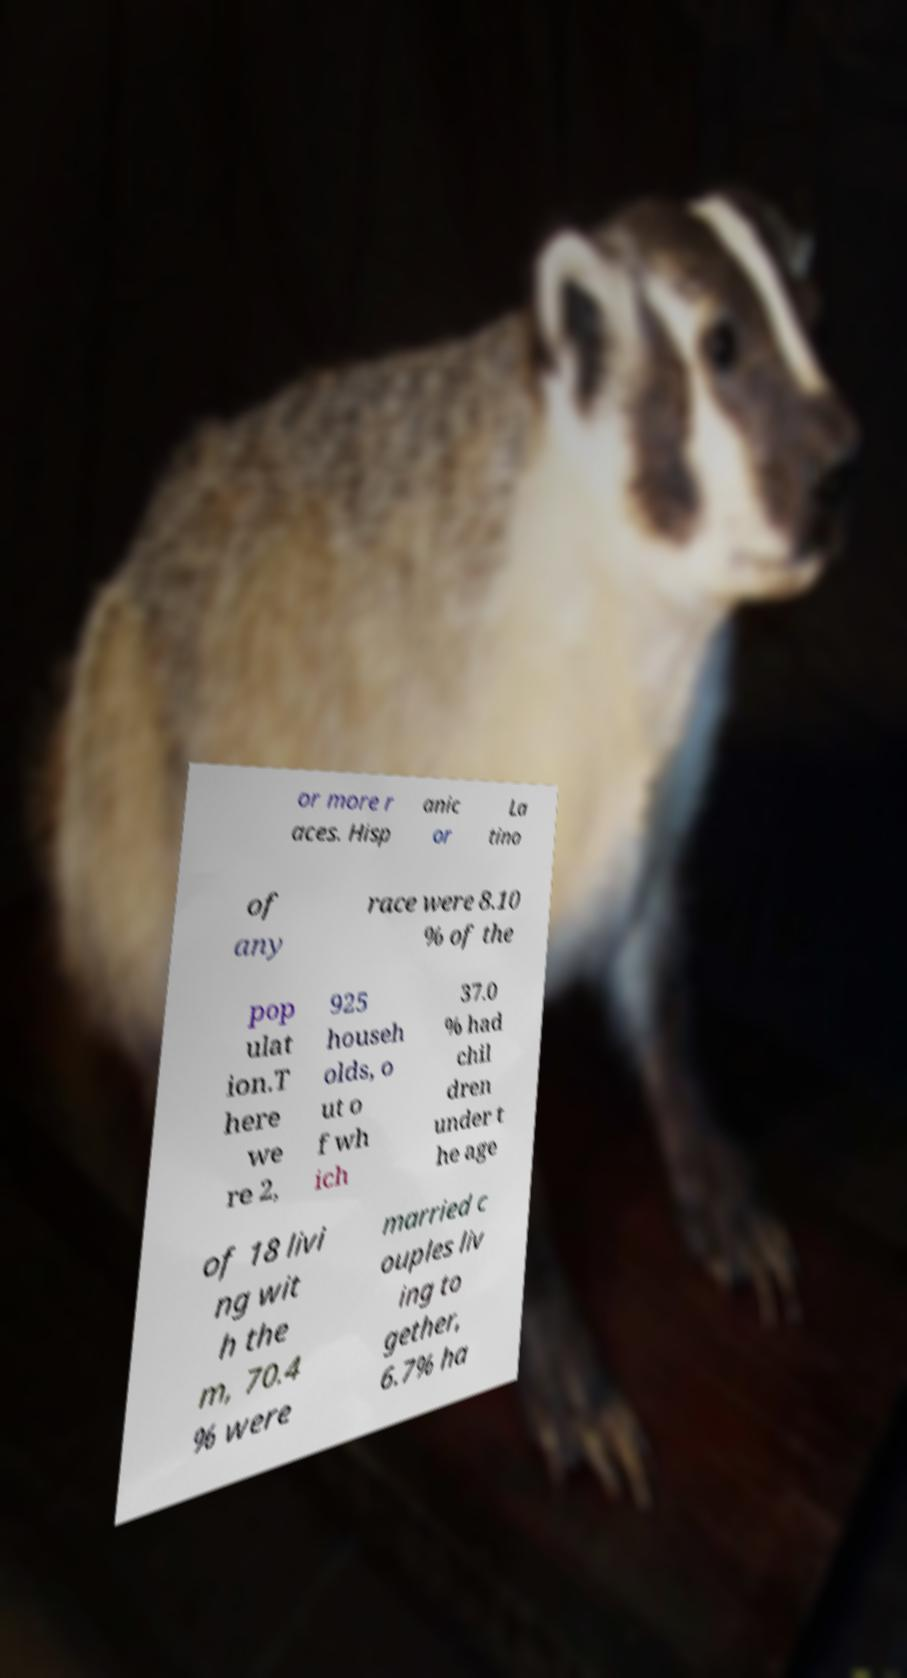Could you extract and type out the text from this image? or more r aces. Hisp anic or La tino of any race were 8.10 % of the pop ulat ion.T here we re 2, 925 househ olds, o ut o f wh ich 37.0 % had chil dren under t he age of 18 livi ng wit h the m, 70.4 % were married c ouples liv ing to gether, 6.7% ha 